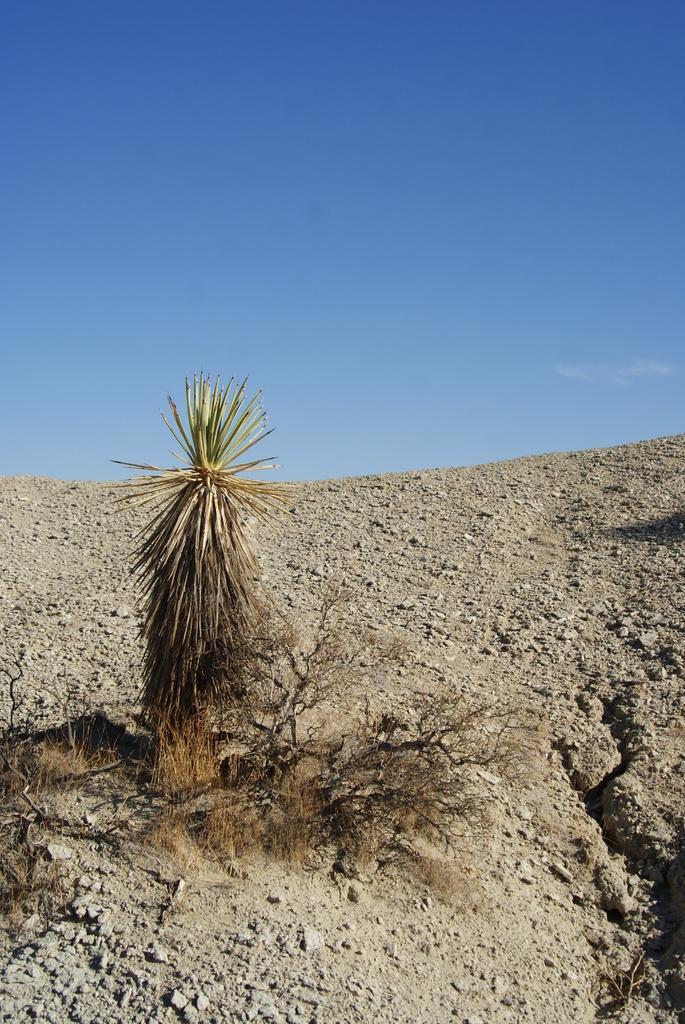Please provide a concise description of this image. In this picture we can see planets on the ground and in the background we can see the sky. 